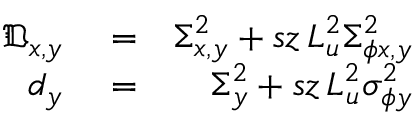<formula> <loc_0><loc_0><loc_500><loc_500>\begin{array} { r l r } { \mathfrak { D } _ { x , y } } & = } & { \Sigma _ { x , y } ^ { 2 } + s z \, L _ { u } ^ { 2 } \Sigma _ { \phi x , y } ^ { 2 } } \\ { \mathfrak { d } _ { y } } & = } & { \Sigma _ { y } ^ { 2 } + s z \, L _ { u } ^ { 2 } \sigma _ { \phi y } ^ { 2 } } \end{array}</formula> 